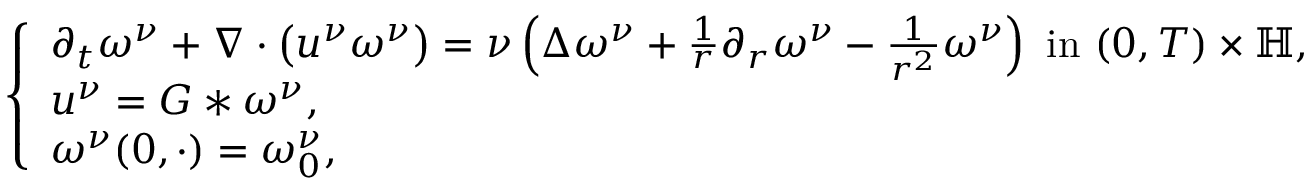<formula> <loc_0><loc_0><loc_500><loc_500>\begin{array} { r } { \left \{ \begin{array} { l l } { \partial _ { t } \omega ^ { \nu } + \nabla \cdot \left ( u ^ { \nu } \omega ^ { \nu } \right ) = \nu \left ( \Delta \omega ^ { \nu } + \frac { 1 } { r } \partial _ { r } \omega ^ { \nu } - \frac { 1 } { r ^ { 2 } } \omega ^ { \nu } \right ) i n ( 0 , T ) \times \mathbb { H } , } \\ { u ^ { \nu } = G \ast \omega ^ { \nu } , } \\ { \omega ^ { \nu } ( 0 , \cdot ) = \omega _ { 0 } ^ { \nu } , } \end{array} } \end{array}</formula> 